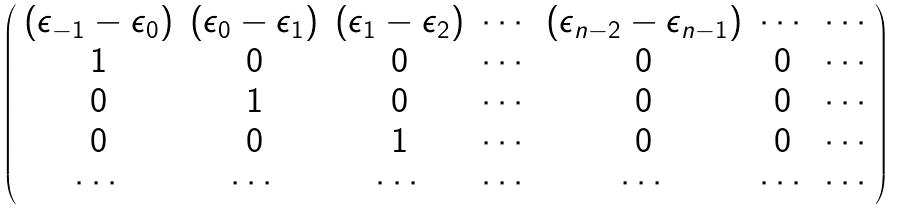Convert formula to latex. <formula><loc_0><loc_0><loc_500><loc_500>\left ( \begin{array} { c c c c c c c } ( \epsilon _ { - 1 } - \epsilon _ { 0 } ) & ( \epsilon _ { 0 } - \epsilon _ { 1 } ) & ( \epsilon _ { 1 } - \epsilon _ { 2 } ) & \cdots & ( \epsilon _ { n - 2 } - \epsilon _ { n - 1 } ) & \cdots & \cdots \\ 1 & 0 & 0 & \cdots & 0 & 0 & \cdots \\ 0 & 1 & 0 & \cdots & 0 & 0 & \cdots \\ 0 & 0 & 1 & \cdots & 0 & 0 & \cdots \\ \cdots & \cdots & \cdots & \cdots & \cdots & \cdots & \cdots \end{array} \right )</formula> 